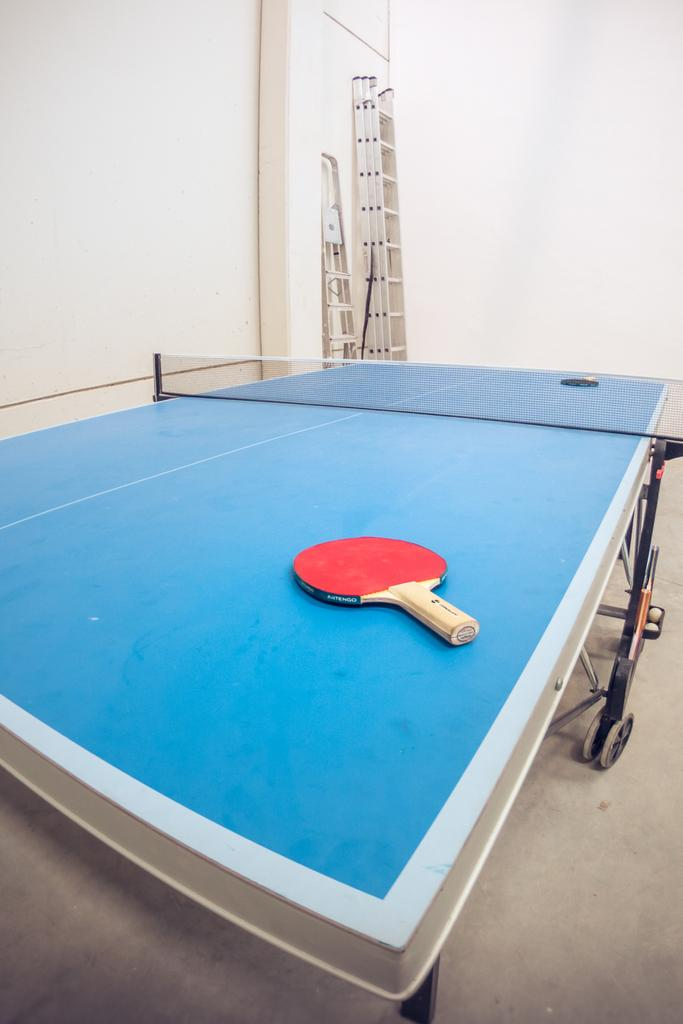What objects are in the image that are used for playing tennis? There are two red tennis bats in the image. Where are the tennis bats located? The tennis bats are on a tennis table. What other objects can be seen in the image? There are two ladders visible in the image. What type of cream is being distributed by the visitor in the image? There is no visitor or cream present in the image. 